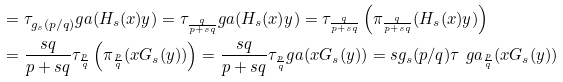Convert formula to latex. <formula><loc_0><loc_0><loc_500><loc_500>& = \tau _ { g _ { s } ( p / q ) } ^ { \ } g a ( H _ { s } ( x ) y ) = \tau _ { \frac { q } { p + s q } } ^ { \ } g a ( H _ { s } ( x ) y ) = \tau _ { \frac { q } { p + s q } } \left ( \pi _ { \frac { q } { p + s q } } ( H _ { s } ( x ) y ) \right ) \\ & = \frac { s q } { p + s q } \tau _ { \frac { p } { q } } \left ( \pi _ { \frac { p } { q } } ( x G _ { s } ( y ) ) \right ) = \frac { s q } { p + s q } \tau _ { \frac { p } { q } } ^ { \ } g a ( x G _ { s } ( y ) ) = s g _ { s } ( p / q ) \tau ^ { \ } g a _ { \frac { p } { q } } ( x G _ { s } ( y ) )</formula> 